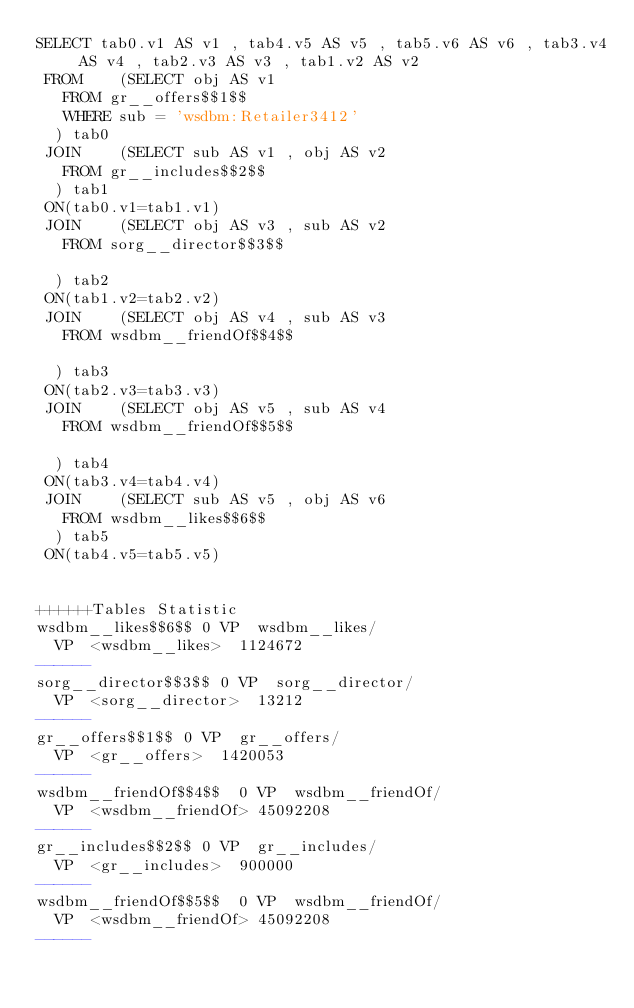<code> <loc_0><loc_0><loc_500><loc_500><_SQL_>SELECT tab0.v1 AS v1 , tab4.v5 AS v5 , tab5.v6 AS v6 , tab3.v4 AS v4 , tab2.v3 AS v3 , tab1.v2 AS v2 
 FROM    (SELECT obj AS v1 
	 FROM gr__offers$$1$$ 
	 WHERE sub = 'wsdbm:Retailer3412'
	) tab0
 JOIN    (SELECT sub AS v1 , obj AS v2 
	 FROM gr__includes$$2$$
	) tab1
 ON(tab0.v1=tab1.v1)
 JOIN    (SELECT obj AS v3 , sub AS v2 
	 FROM sorg__director$$3$$
	
	) tab2
 ON(tab1.v2=tab2.v2)
 JOIN    (SELECT obj AS v4 , sub AS v3 
	 FROM wsdbm__friendOf$$4$$
	
	) tab3
 ON(tab2.v3=tab3.v3)
 JOIN    (SELECT obj AS v5 , sub AS v4 
	 FROM wsdbm__friendOf$$5$$
	
	) tab4
 ON(tab3.v4=tab4.v4)
 JOIN    (SELECT sub AS v5 , obj AS v6 
	 FROM wsdbm__likes$$6$$
	) tab5
 ON(tab4.v5=tab5.v5)


++++++Tables Statistic
wsdbm__likes$$6$$	0	VP	wsdbm__likes/
	VP	<wsdbm__likes>	1124672
------
sorg__director$$3$$	0	VP	sorg__director/
	VP	<sorg__director>	13212
------
gr__offers$$1$$	0	VP	gr__offers/
	VP	<gr__offers>	1420053
------
wsdbm__friendOf$$4$$	0	VP	wsdbm__friendOf/
	VP	<wsdbm__friendOf>	45092208
------
gr__includes$$2$$	0	VP	gr__includes/
	VP	<gr__includes>	900000
------
wsdbm__friendOf$$5$$	0	VP	wsdbm__friendOf/
	VP	<wsdbm__friendOf>	45092208
------
</code> 